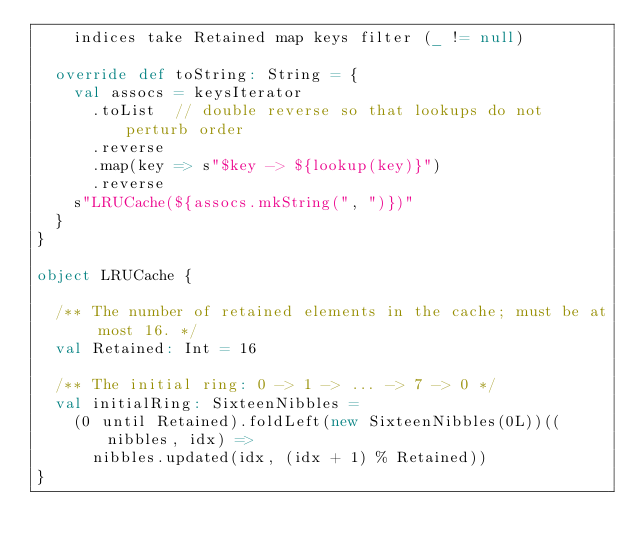Convert code to text. <code><loc_0><loc_0><loc_500><loc_500><_Scala_>    indices take Retained map keys filter (_ != null)

  override def toString: String = {
    val assocs = keysIterator
      .toList  // double reverse so that lookups do not perturb order
      .reverse
      .map(key => s"$key -> ${lookup(key)}")
      .reverse
    s"LRUCache(${assocs.mkString(", ")})"
  }
}

object LRUCache {

  /** The number of retained elements in the cache; must be at most 16. */
  val Retained: Int = 16

  /** The initial ring: 0 -> 1 -> ... -> 7 -> 0 */
  val initialRing: SixteenNibbles =
    (0 until Retained).foldLeft(new SixteenNibbles(0L))((nibbles, idx) =>
      nibbles.updated(idx, (idx + 1) % Retained))
}
</code> 